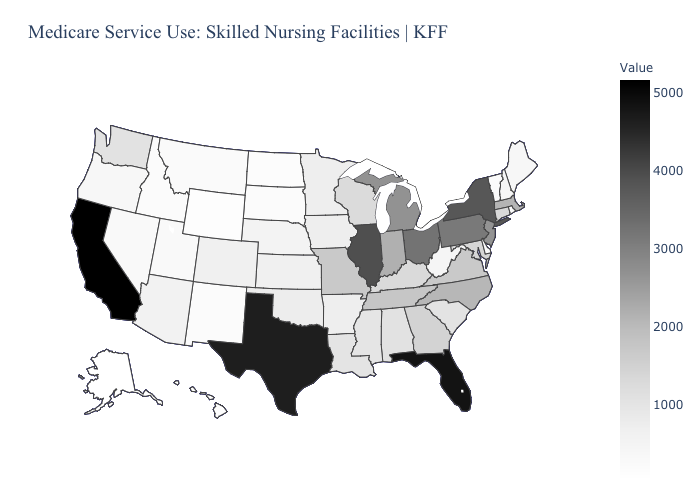Does Wisconsin have the lowest value in the MidWest?
Quick response, please. No. Which states have the lowest value in the MidWest?
Give a very brief answer. North Dakota. Does the map have missing data?
Concise answer only. No. Does Wisconsin have a lower value than Utah?
Answer briefly. No. Which states have the lowest value in the MidWest?
Give a very brief answer. North Dakota. Which states have the highest value in the USA?
Answer briefly. California. Which states have the highest value in the USA?
Be succinct. California. 